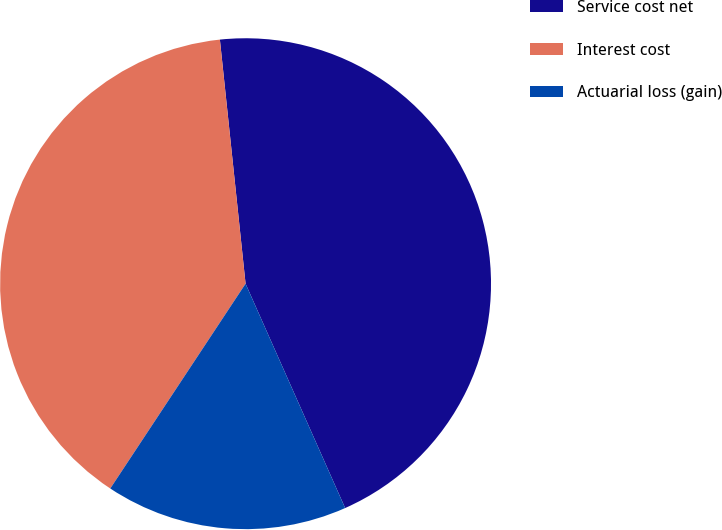Convert chart to OTSL. <chart><loc_0><loc_0><loc_500><loc_500><pie_chart><fcel>Service cost net<fcel>Interest cost<fcel>Actuarial loss (gain)<nl><fcel>45.02%<fcel>39.04%<fcel>15.94%<nl></chart> 